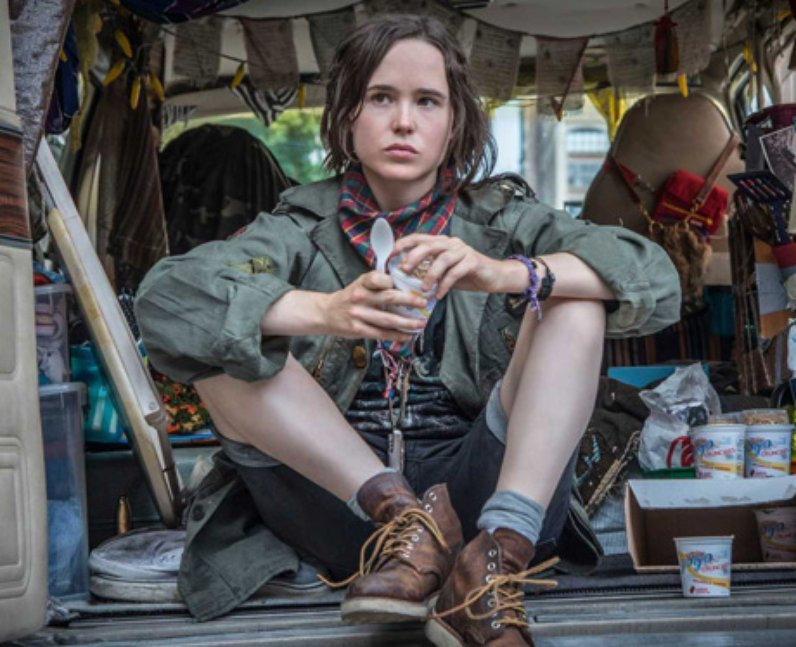What do you think the person in the image might be thinking about? The person in the image might be deep in thought about their next destination or reminiscing about past experiences. Given the cluttered yet homey atmosphere of the van, they might be contemplating the journey they've been on, the people they've met, or the adventures that lie ahead. The serious expression suggests that whatever they are thinking about holds significant importance to them. 